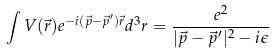Convert formula to latex. <formula><loc_0><loc_0><loc_500><loc_500>\int V ( { \vec { r } } ) e ^ { - i ( { \vec { p } } - { \vec { p } } ^ { \prime } ) { \vec { r } } } d ^ { 3 } r = { \frac { e ^ { 2 } } { | { \vec { p } } - { \vec { p } } ^ { \prime } | ^ { 2 } - i \epsilon } }</formula> 